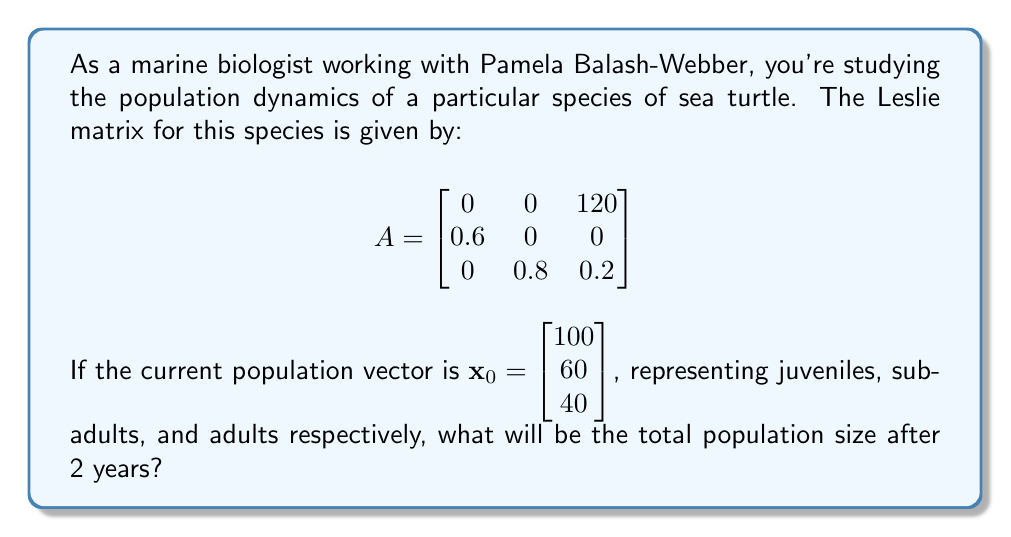Teach me how to tackle this problem. To solve this problem, we need to follow these steps:

1) The Leslie matrix $A$ represents the transition probabilities and fecundity rates for the sea turtle population. 

2) To find the population after 2 years, we need to multiply the initial population vector by the Leslie matrix twice:

   $\mathbf{x}_2 = A^2 \mathbf{x}_0$

3) First, let's calculate $A^2$:

   $$A^2 = \begin{bmatrix}
   0 & 0 & 120 \\
   0.6 & 0 & 0 \\
   0 & 0.8 & 0.2
   \end{bmatrix} \times 
   \begin{bmatrix}
   0 & 0 & 120 \\
   0.6 & 0 & 0 \\
   0 & 0.8 & 0.2
   \end{bmatrix} = 
   \begin{bmatrix}
   0 & 96 & 24 \\
   0 & 0 & 72 \\
   0.48 & 0.16 & 0.16
   \end{bmatrix}$$

4) Now, we multiply $A^2$ by $\mathbf{x}_0$:

   $$\mathbf{x}_2 = \begin{bmatrix}
   0 & 96 & 24 \\
   0 & 0 & 72 \\
   0.48 & 0.16 & 0.16
   \end{bmatrix} \times 
   \begin{bmatrix}
   100 \\
   60 \\
   40
   \end{bmatrix} = 
   \begin{bmatrix}
   0(100) + 96(60) + 24(40) \\
   0(100) + 0(60) + 72(40) \\
   0.48(100) + 0.16(60) + 0.16(40)
   \end{bmatrix} = 
   \begin{bmatrix}
   6720 \\
   2880 \\
   67.2
   \end{bmatrix}$$

5) The total population size after 2 years is the sum of all elements in $\mathbf{x}_2$:

   Total = 6720 + 2880 + 67.2 = 9667.2

6) Since we're dealing with whole organisms, we round to the nearest integer: 9667.
Answer: 9667 